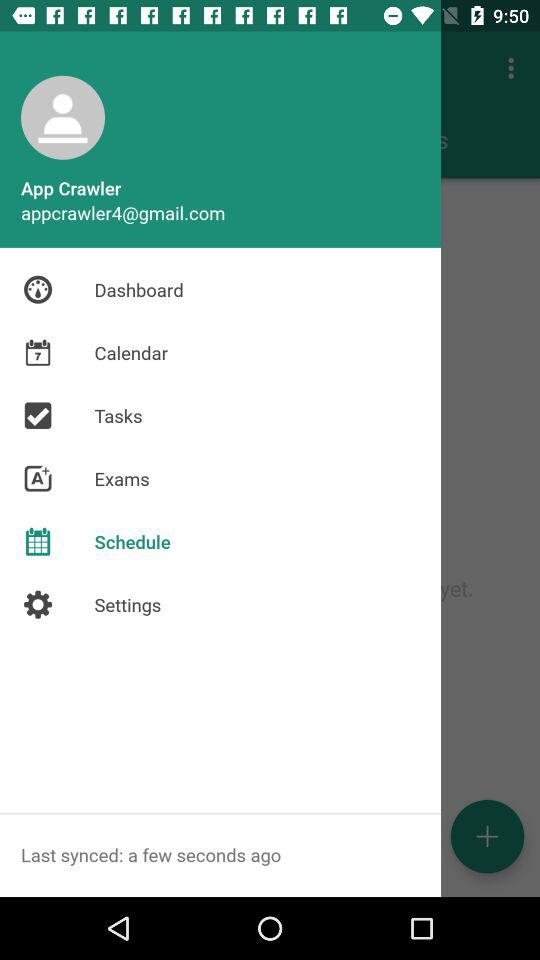What is the user's name? The user's name is App Crawler. 